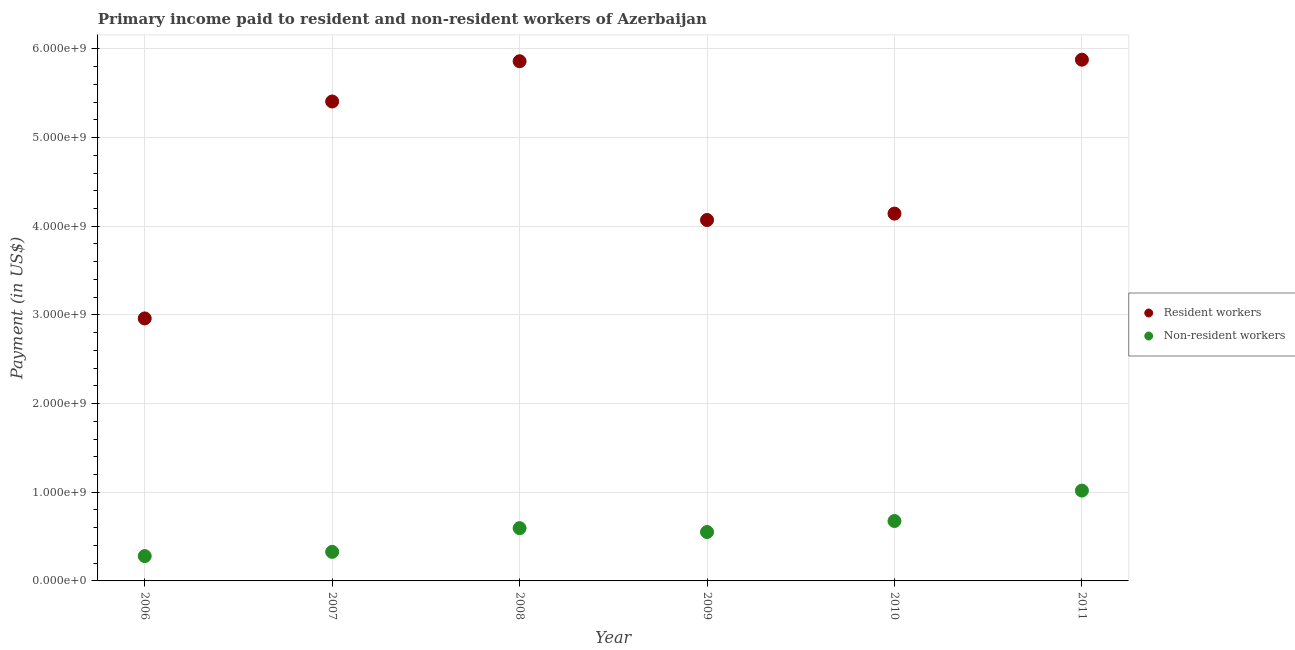Is the number of dotlines equal to the number of legend labels?
Ensure brevity in your answer.  Yes. What is the payment made to resident workers in 2011?
Offer a very short reply. 5.88e+09. Across all years, what is the maximum payment made to non-resident workers?
Keep it short and to the point. 1.02e+09. Across all years, what is the minimum payment made to non-resident workers?
Give a very brief answer. 2.80e+08. In which year was the payment made to resident workers maximum?
Ensure brevity in your answer.  2011. In which year was the payment made to non-resident workers minimum?
Offer a terse response. 2006. What is the total payment made to non-resident workers in the graph?
Your answer should be compact. 3.45e+09. What is the difference between the payment made to non-resident workers in 2007 and that in 2011?
Make the answer very short. -6.91e+08. What is the difference between the payment made to non-resident workers in 2007 and the payment made to resident workers in 2006?
Your response must be concise. -2.63e+09. What is the average payment made to resident workers per year?
Ensure brevity in your answer.  4.72e+09. In the year 2006, what is the difference between the payment made to resident workers and payment made to non-resident workers?
Provide a succinct answer. 2.68e+09. In how many years, is the payment made to non-resident workers greater than 1400000000 US$?
Your answer should be very brief. 0. What is the ratio of the payment made to non-resident workers in 2007 to that in 2009?
Provide a short and direct response. 0.59. Is the payment made to non-resident workers in 2006 less than that in 2007?
Your answer should be compact. Yes. Is the difference between the payment made to resident workers in 2007 and 2008 greater than the difference between the payment made to non-resident workers in 2007 and 2008?
Provide a short and direct response. No. What is the difference between the highest and the second highest payment made to resident workers?
Keep it short and to the point. 1.74e+07. What is the difference between the highest and the lowest payment made to resident workers?
Your answer should be very brief. 2.92e+09. Is the sum of the payment made to resident workers in 2008 and 2011 greater than the maximum payment made to non-resident workers across all years?
Offer a terse response. Yes. Does the payment made to resident workers monotonically increase over the years?
Ensure brevity in your answer.  No. Is the payment made to non-resident workers strictly greater than the payment made to resident workers over the years?
Your response must be concise. No. Is the payment made to non-resident workers strictly less than the payment made to resident workers over the years?
Your answer should be very brief. Yes. Does the graph contain any zero values?
Your answer should be very brief. No. How are the legend labels stacked?
Ensure brevity in your answer.  Vertical. What is the title of the graph?
Offer a very short reply. Primary income paid to resident and non-resident workers of Azerbaijan. What is the label or title of the Y-axis?
Provide a short and direct response. Payment (in US$). What is the Payment (in US$) of Resident workers in 2006?
Give a very brief answer. 2.96e+09. What is the Payment (in US$) of Non-resident workers in 2006?
Offer a very short reply. 2.80e+08. What is the Payment (in US$) in Resident workers in 2007?
Ensure brevity in your answer.  5.41e+09. What is the Payment (in US$) in Non-resident workers in 2007?
Keep it short and to the point. 3.28e+08. What is the Payment (in US$) of Resident workers in 2008?
Offer a very short reply. 5.86e+09. What is the Payment (in US$) in Non-resident workers in 2008?
Your response must be concise. 5.95e+08. What is the Payment (in US$) of Resident workers in 2009?
Keep it short and to the point. 4.07e+09. What is the Payment (in US$) of Non-resident workers in 2009?
Your answer should be very brief. 5.51e+08. What is the Payment (in US$) of Resident workers in 2010?
Ensure brevity in your answer.  4.14e+09. What is the Payment (in US$) in Non-resident workers in 2010?
Provide a succinct answer. 6.76e+08. What is the Payment (in US$) of Resident workers in 2011?
Your answer should be compact. 5.88e+09. What is the Payment (in US$) of Non-resident workers in 2011?
Your answer should be very brief. 1.02e+09. Across all years, what is the maximum Payment (in US$) in Resident workers?
Your response must be concise. 5.88e+09. Across all years, what is the maximum Payment (in US$) in Non-resident workers?
Offer a terse response. 1.02e+09. Across all years, what is the minimum Payment (in US$) of Resident workers?
Give a very brief answer. 2.96e+09. Across all years, what is the minimum Payment (in US$) in Non-resident workers?
Make the answer very short. 2.80e+08. What is the total Payment (in US$) in Resident workers in the graph?
Keep it short and to the point. 2.83e+1. What is the total Payment (in US$) of Non-resident workers in the graph?
Your response must be concise. 3.45e+09. What is the difference between the Payment (in US$) in Resident workers in 2006 and that in 2007?
Provide a succinct answer. -2.45e+09. What is the difference between the Payment (in US$) of Non-resident workers in 2006 and that in 2007?
Your answer should be very brief. -4.78e+07. What is the difference between the Payment (in US$) of Resident workers in 2006 and that in 2008?
Your answer should be very brief. -2.90e+09. What is the difference between the Payment (in US$) in Non-resident workers in 2006 and that in 2008?
Your answer should be compact. -3.15e+08. What is the difference between the Payment (in US$) in Resident workers in 2006 and that in 2009?
Provide a short and direct response. -1.11e+09. What is the difference between the Payment (in US$) in Non-resident workers in 2006 and that in 2009?
Your answer should be compact. -2.71e+08. What is the difference between the Payment (in US$) of Resident workers in 2006 and that in 2010?
Ensure brevity in your answer.  -1.18e+09. What is the difference between the Payment (in US$) in Non-resident workers in 2006 and that in 2010?
Provide a short and direct response. -3.96e+08. What is the difference between the Payment (in US$) in Resident workers in 2006 and that in 2011?
Give a very brief answer. -2.92e+09. What is the difference between the Payment (in US$) in Non-resident workers in 2006 and that in 2011?
Your answer should be compact. -7.39e+08. What is the difference between the Payment (in US$) in Resident workers in 2007 and that in 2008?
Your answer should be very brief. -4.54e+08. What is the difference between the Payment (in US$) of Non-resident workers in 2007 and that in 2008?
Keep it short and to the point. -2.67e+08. What is the difference between the Payment (in US$) in Resident workers in 2007 and that in 2009?
Offer a very short reply. 1.34e+09. What is the difference between the Payment (in US$) in Non-resident workers in 2007 and that in 2009?
Ensure brevity in your answer.  -2.24e+08. What is the difference between the Payment (in US$) of Resident workers in 2007 and that in 2010?
Ensure brevity in your answer.  1.26e+09. What is the difference between the Payment (in US$) in Non-resident workers in 2007 and that in 2010?
Offer a very short reply. -3.48e+08. What is the difference between the Payment (in US$) in Resident workers in 2007 and that in 2011?
Offer a very short reply. -4.71e+08. What is the difference between the Payment (in US$) of Non-resident workers in 2007 and that in 2011?
Provide a short and direct response. -6.91e+08. What is the difference between the Payment (in US$) in Resident workers in 2008 and that in 2009?
Keep it short and to the point. 1.79e+09. What is the difference between the Payment (in US$) of Non-resident workers in 2008 and that in 2009?
Offer a terse response. 4.37e+07. What is the difference between the Payment (in US$) in Resident workers in 2008 and that in 2010?
Provide a short and direct response. 1.72e+09. What is the difference between the Payment (in US$) in Non-resident workers in 2008 and that in 2010?
Your answer should be very brief. -8.04e+07. What is the difference between the Payment (in US$) in Resident workers in 2008 and that in 2011?
Your response must be concise. -1.74e+07. What is the difference between the Payment (in US$) in Non-resident workers in 2008 and that in 2011?
Ensure brevity in your answer.  -4.24e+08. What is the difference between the Payment (in US$) in Resident workers in 2009 and that in 2010?
Give a very brief answer. -7.20e+07. What is the difference between the Payment (in US$) of Non-resident workers in 2009 and that in 2010?
Give a very brief answer. -1.24e+08. What is the difference between the Payment (in US$) in Resident workers in 2009 and that in 2011?
Offer a terse response. -1.81e+09. What is the difference between the Payment (in US$) in Non-resident workers in 2009 and that in 2011?
Ensure brevity in your answer.  -4.67e+08. What is the difference between the Payment (in US$) in Resident workers in 2010 and that in 2011?
Provide a succinct answer. -1.74e+09. What is the difference between the Payment (in US$) in Non-resident workers in 2010 and that in 2011?
Provide a short and direct response. -3.43e+08. What is the difference between the Payment (in US$) in Resident workers in 2006 and the Payment (in US$) in Non-resident workers in 2007?
Your response must be concise. 2.63e+09. What is the difference between the Payment (in US$) in Resident workers in 2006 and the Payment (in US$) in Non-resident workers in 2008?
Your answer should be very brief. 2.37e+09. What is the difference between the Payment (in US$) in Resident workers in 2006 and the Payment (in US$) in Non-resident workers in 2009?
Offer a very short reply. 2.41e+09. What is the difference between the Payment (in US$) in Resident workers in 2006 and the Payment (in US$) in Non-resident workers in 2010?
Your response must be concise. 2.29e+09. What is the difference between the Payment (in US$) in Resident workers in 2006 and the Payment (in US$) in Non-resident workers in 2011?
Offer a terse response. 1.94e+09. What is the difference between the Payment (in US$) of Resident workers in 2007 and the Payment (in US$) of Non-resident workers in 2008?
Your answer should be very brief. 4.81e+09. What is the difference between the Payment (in US$) in Resident workers in 2007 and the Payment (in US$) in Non-resident workers in 2009?
Keep it short and to the point. 4.86e+09. What is the difference between the Payment (in US$) of Resident workers in 2007 and the Payment (in US$) of Non-resident workers in 2010?
Offer a very short reply. 4.73e+09. What is the difference between the Payment (in US$) of Resident workers in 2007 and the Payment (in US$) of Non-resident workers in 2011?
Your response must be concise. 4.39e+09. What is the difference between the Payment (in US$) of Resident workers in 2008 and the Payment (in US$) of Non-resident workers in 2009?
Ensure brevity in your answer.  5.31e+09. What is the difference between the Payment (in US$) of Resident workers in 2008 and the Payment (in US$) of Non-resident workers in 2010?
Your answer should be compact. 5.19e+09. What is the difference between the Payment (in US$) in Resident workers in 2008 and the Payment (in US$) in Non-resident workers in 2011?
Offer a very short reply. 4.84e+09. What is the difference between the Payment (in US$) in Resident workers in 2009 and the Payment (in US$) in Non-resident workers in 2010?
Your response must be concise. 3.40e+09. What is the difference between the Payment (in US$) in Resident workers in 2009 and the Payment (in US$) in Non-resident workers in 2011?
Offer a very short reply. 3.05e+09. What is the difference between the Payment (in US$) of Resident workers in 2010 and the Payment (in US$) of Non-resident workers in 2011?
Keep it short and to the point. 3.12e+09. What is the average Payment (in US$) of Resident workers per year?
Your response must be concise. 4.72e+09. What is the average Payment (in US$) in Non-resident workers per year?
Keep it short and to the point. 5.75e+08. In the year 2006, what is the difference between the Payment (in US$) of Resident workers and Payment (in US$) of Non-resident workers?
Make the answer very short. 2.68e+09. In the year 2007, what is the difference between the Payment (in US$) of Resident workers and Payment (in US$) of Non-resident workers?
Ensure brevity in your answer.  5.08e+09. In the year 2008, what is the difference between the Payment (in US$) in Resident workers and Payment (in US$) in Non-resident workers?
Make the answer very short. 5.27e+09. In the year 2009, what is the difference between the Payment (in US$) in Resident workers and Payment (in US$) in Non-resident workers?
Offer a very short reply. 3.52e+09. In the year 2010, what is the difference between the Payment (in US$) of Resident workers and Payment (in US$) of Non-resident workers?
Your answer should be very brief. 3.47e+09. In the year 2011, what is the difference between the Payment (in US$) of Resident workers and Payment (in US$) of Non-resident workers?
Provide a short and direct response. 4.86e+09. What is the ratio of the Payment (in US$) of Resident workers in 2006 to that in 2007?
Your response must be concise. 0.55. What is the ratio of the Payment (in US$) in Non-resident workers in 2006 to that in 2007?
Your answer should be very brief. 0.85. What is the ratio of the Payment (in US$) of Resident workers in 2006 to that in 2008?
Offer a terse response. 0.51. What is the ratio of the Payment (in US$) in Non-resident workers in 2006 to that in 2008?
Your response must be concise. 0.47. What is the ratio of the Payment (in US$) of Resident workers in 2006 to that in 2009?
Offer a very short reply. 0.73. What is the ratio of the Payment (in US$) in Non-resident workers in 2006 to that in 2009?
Offer a very short reply. 0.51. What is the ratio of the Payment (in US$) in Resident workers in 2006 to that in 2010?
Provide a short and direct response. 0.71. What is the ratio of the Payment (in US$) of Non-resident workers in 2006 to that in 2010?
Give a very brief answer. 0.41. What is the ratio of the Payment (in US$) in Resident workers in 2006 to that in 2011?
Offer a very short reply. 0.5. What is the ratio of the Payment (in US$) of Non-resident workers in 2006 to that in 2011?
Your answer should be very brief. 0.27. What is the ratio of the Payment (in US$) in Resident workers in 2007 to that in 2008?
Give a very brief answer. 0.92. What is the ratio of the Payment (in US$) of Non-resident workers in 2007 to that in 2008?
Your response must be concise. 0.55. What is the ratio of the Payment (in US$) in Resident workers in 2007 to that in 2009?
Offer a terse response. 1.33. What is the ratio of the Payment (in US$) of Non-resident workers in 2007 to that in 2009?
Provide a short and direct response. 0.59. What is the ratio of the Payment (in US$) in Resident workers in 2007 to that in 2010?
Provide a succinct answer. 1.31. What is the ratio of the Payment (in US$) of Non-resident workers in 2007 to that in 2010?
Your answer should be very brief. 0.49. What is the ratio of the Payment (in US$) of Resident workers in 2007 to that in 2011?
Your response must be concise. 0.92. What is the ratio of the Payment (in US$) in Non-resident workers in 2007 to that in 2011?
Give a very brief answer. 0.32. What is the ratio of the Payment (in US$) of Resident workers in 2008 to that in 2009?
Provide a succinct answer. 1.44. What is the ratio of the Payment (in US$) in Non-resident workers in 2008 to that in 2009?
Ensure brevity in your answer.  1.08. What is the ratio of the Payment (in US$) of Resident workers in 2008 to that in 2010?
Ensure brevity in your answer.  1.41. What is the ratio of the Payment (in US$) of Non-resident workers in 2008 to that in 2010?
Ensure brevity in your answer.  0.88. What is the ratio of the Payment (in US$) in Resident workers in 2008 to that in 2011?
Provide a short and direct response. 1. What is the ratio of the Payment (in US$) of Non-resident workers in 2008 to that in 2011?
Keep it short and to the point. 0.58. What is the ratio of the Payment (in US$) of Resident workers in 2009 to that in 2010?
Your response must be concise. 0.98. What is the ratio of the Payment (in US$) in Non-resident workers in 2009 to that in 2010?
Provide a short and direct response. 0.82. What is the ratio of the Payment (in US$) of Resident workers in 2009 to that in 2011?
Provide a short and direct response. 0.69. What is the ratio of the Payment (in US$) in Non-resident workers in 2009 to that in 2011?
Ensure brevity in your answer.  0.54. What is the ratio of the Payment (in US$) in Resident workers in 2010 to that in 2011?
Your answer should be very brief. 0.7. What is the ratio of the Payment (in US$) in Non-resident workers in 2010 to that in 2011?
Provide a succinct answer. 0.66. What is the difference between the highest and the second highest Payment (in US$) of Resident workers?
Provide a succinct answer. 1.74e+07. What is the difference between the highest and the second highest Payment (in US$) in Non-resident workers?
Ensure brevity in your answer.  3.43e+08. What is the difference between the highest and the lowest Payment (in US$) in Resident workers?
Your answer should be compact. 2.92e+09. What is the difference between the highest and the lowest Payment (in US$) of Non-resident workers?
Keep it short and to the point. 7.39e+08. 